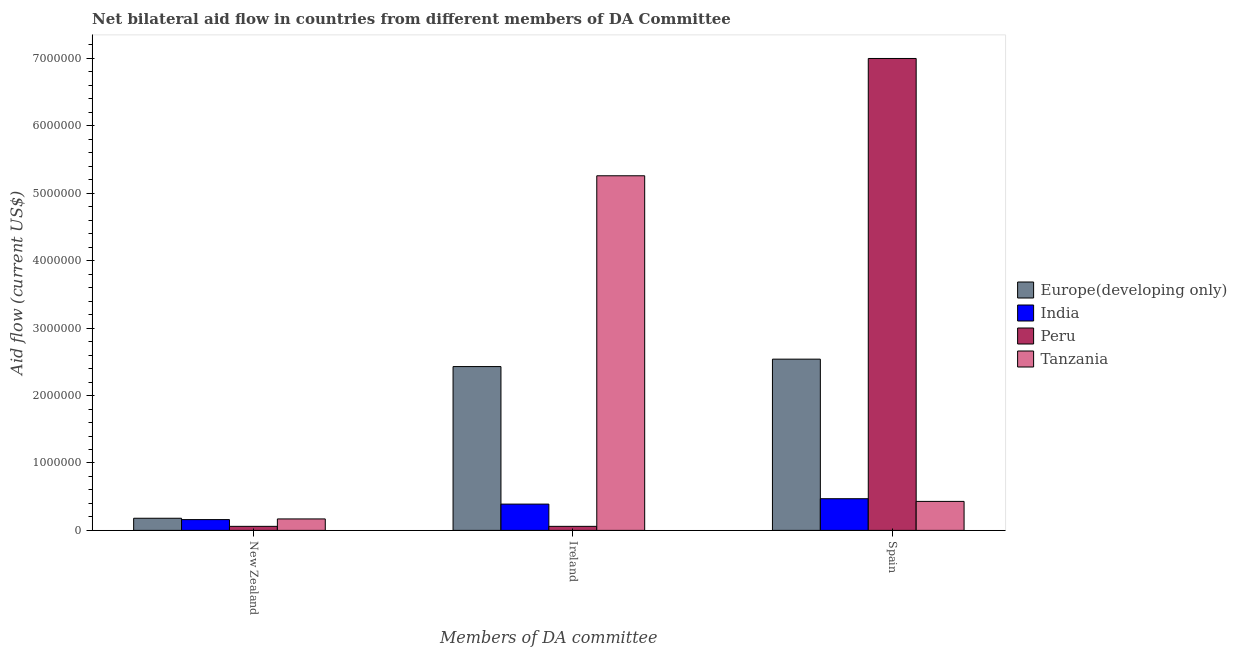How many different coloured bars are there?
Your answer should be compact. 4. How many groups of bars are there?
Your answer should be compact. 3. What is the label of the 1st group of bars from the left?
Provide a short and direct response. New Zealand. What is the amount of aid provided by ireland in Peru?
Your answer should be very brief. 6.00e+04. Across all countries, what is the maximum amount of aid provided by ireland?
Offer a terse response. 5.26e+06. Across all countries, what is the minimum amount of aid provided by spain?
Your answer should be very brief. 4.30e+05. In which country was the amount of aid provided by ireland maximum?
Provide a succinct answer. Tanzania. In which country was the amount of aid provided by spain minimum?
Make the answer very short. Tanzania. What is the total amount of aid provided by spain in the graph?
Your response must be concise. 1.04e+07. What is the difference between the amount of aid provided by new zealand in Tanzania and that in Europe(developing only)?
Provide a short and direct response. -10000. What is the difference between the amount of aid provided by ireland in Europe(developing only) and the amount of aid provided by spain in India?
Ensure brevity in your answer.  1.96e+06. What is the average amount of aid provided by spain per country?
Provide a succinct answer. 2.61e+06. What is the difference between the amount of aid provided by new zealand and amount of aid provided by spain in Tanzania?
Your answer should be compact. -2.60e+05. What is the difference between the highest and the second highest amount of aid provided by spain?
Give a very brief answer. 4.46e+06. What is the difference between the highest and the lowest amount of aid provided by ireland?
Your answer should be very brief. 5.20e+06. What does the 2nd bar from the left in New Zealand represents?
Give a very brief answer. India. What does the 3rd bar from the right in Ireland represents?
Make the answer very short. India. How many countries are there in the graph?
Provide a succinct answer. 4. What is the difference between two consecutive major ticks on the Y-axis?
Provide a succinct answer. 1.00e+06. Does the graph contain any zero values?
Keep it short and to the point. No. Does the graph contain grids?
Make the answer very short. No. Where does the legend appear in the graph?
Keep it short and to the point. Center right. How many legend labels are there?
Your answer should be very brief. 4. What is the title of the graph?
Give a very brief answer. Net bilateral aid flow in countries from different members of DA Committee. What is the label or title of the X-axis?
Your answer should be compact. Members of DA committee. What is the Aid flow (current US$) in India in New Zealand?
Give a very brief answer. 1.60e+05. What is the Aid flow (current US$) of Europe(developing only) in Ireland?
Offer a very short reply. 2.43e+06. What is the Aid flow (current US$) of Tanzania in Ireland?
Ensure brevity in your answer.  5.26e+06. What is the Aid flow (current US$) in Europe(developing only) in Spain?
Offer a terse response. 2.54e+06. What is the Aid flow (current US$) in India in Spain?
Ensure brevity in your answer.  4.70e+05. What is the Aid flow (current US$) in Peru in Spain?
Give a very brief answer. 7.00e+06. What is the Aid flow (current US$) in Tanzania in Spain?
Your answer should be compact. 4.30e+05. Across all Members of DA committee, what is the maximum Aid flow (current US$) of Europe(developing only)?
Your answer should be very brief. 2.54e+06. Across all Members of DA committee, what is the maximum Aid flow (current US$) of Tanzania?
Ensure brevity in your answer.  5.26e+06. Across all Members of DA committee, what is the minimum Aid flow (current US$) in Europe(developing only)?
Offer a terse response. 1.80e+05. Across all Members of DA committee, what is the minimum Aid flow (current US$) of Peru?
Offer a terse response. 6.00e+04. What is the total Aid flow (current US$) of Europe(developing only) in the graph?
Your answer should be compact. 5.15e+06. What is the total Aid flow (current US$) of India in the graph?
Provide a succinct answer. 1.02e+06. What is the total Aid flow (current US$) of Peru in the graph?
Provide a succinct answer. 7.12e+06. What is the total Aid flow (current US$) of Tanzania in the graph?
Offer a very short reply. 5.86e+06. What is the difference between the Aid flow (current US$) of Europe(developing only) in New Zealand and that in Ireland?
Give a very brief answer. -2.25e+06. What is the difference between the Aid flow (current US$) in India in New Zealand and that in Ireland?
Offer a terse response. -2.30e+05. What is the difference between the Aid flow (current US$) of Peru in New Zealand and that in Ireland?
Your answer should be very brief. 0. What is the difference between the Aid flow (current US$) in Tanzania in New Zealand and that in Ireland?
Provide a succinct answer. -5.09e+06. What is the difference between the Aid flow (current US$) of Europe(developing only) in New Zealand and that in Spain?
Keep it short and to the point. -2.36e+06. What is the difference between the Aid flow (current US$) in India in New Zealand and that in Spain?
Your response must be concise. -3.10e+05. What is the difference between the Aid flow (current US$) in Peru in New Zealand and that in Spain?
Your answer should be very brief. -6.94e+06. What is the difference between the Aid flow (current US$) in India in Ireland and that in Spain?
Give a very brief answer. -8.00e+04. What is the difference between the Aid flow (current US$) in Peru in Ireland and that in Spain?
Offer a terse response. -6.94e+06. What is the difference between the Aid flow (current US$) of Tanzania in Ireland and that in Spain?
Your answer should be compact. 4.83e+06. What is the difference between the Aid flow (current US$) of Europe(developing only) in New Zealand and the Aid flow (current US$) of India in Ireland?
Keep it short and to the point. -2.10e+05. What is the difference between the Aid flow (current US$) of Europe(developing only) in New Zealand and the Aid flow (current US$) of Tanzania in Ireland?
Give a very brief answer. -5.08e+06. What is the difference between the Aid flow (current US$) in India in New Zealand and the Aid flow (current US$) in Peru in Ireland?
Give a very brief answer. 1.00e+05. What is the difference between the Aid flow (current US$) of India in New Zealand and the Aid flow (current US$) of Tanzania in Ireland?
Keep it short and to the point. -5.10e+06. What is the difference between the Aid flow (current US$) of Peru in New Zealand and the Aid flow (current US$) of Tanzania in Ireland?
Provide a short and direct response. -5.20e+06. What is the difference between the Aid flow (current US$) in Europe(developing only) in New Zealand and the Aid flow (current US$) in Peru in Spain?
Keep it short and to the point. -6.82e+06. What is the difference between the Aid flow (current US$) in Europe(developing only) in New Zealand and the Aid flow (current US$) in Tanzania in Spain?
Make the answer very short. -2.50e+05. What is the difference between the Aid flow (current US$) of India in New Zealand and the Aid flow (current US$) of Peru in Spain?
Make the answer very short. -6.84e+06. What is the difference between the Aid flow (current US$) in India in New Zealand and the Aid flow (current US$) in Tanzania in Spain?
Provide a short and direct response. -2.70e+05. What is the difference between the Aid flow (current US$) in Peru in New Zealand and the Aid flow (current US$) in Tanzania in Spain?
Provide a short and direct response. -3.70e+05. What is the difference between the Aid flow (current US$) of Europe(developing only) in Ireland and the Aid flow (current US$) of India in Spain?
Offer a very short reply. 1.96e+06. What is the difference between the Aid flow (current US$) of Europe(developing only) in Ireland and the Aid flow (current US$) of Peru in Spain?
Your answer should be compact. -4.57e+06. What is the difference between the Aid flow (current US$) of India in Ireland and the Aid flow (current US$) of Peru in Spain?
Make the answer very short. -6.61e+06. What is the difference between the Aid flow (current US$) in India in Ireland and the Aid flow (current US$) in Tanzania in Spain?
Ensure brevity in your answer.  -4.00e+04. What is the difference between the Aid flow (current US$) in Peru in Ireland and the Aid flow (current US$) in Tanzania in Spain?
Your answer should be very brief. -3.70e+05. What is the average Aid flow (current US$) of Europe(developing only) per Members of DA committee?
Provide a short and direct response. 1.72e+06. What is the average Aid flow (current US$) of India per Members of DA committee?
Offer a terse response. 3.40e+05. What is the average Aid flow (current US$) in Peru per Members of DA committee?
Offer a very short reply. 2.37e+06. What is the average Aid flow (current US$) of Tanzania per Members of DA committee?
Make the answer very short. 1.95e+06. What is the difference between the Aid flow (current US$) in Europe(developing only) and Aid flow (current US$) in India in New Zealand?
Provide a succinct answer. 2.00e+04. What is the difference between the Aid flow (current US$) of Europe(developing only) and Aid flow (current US$) of Peru in New Zealand?
Offer a very short reply. 1.20e+05. What is the difference between the Aid flow (current US$) of Europe(developing only) and Aid flow (current US$) of Tanzania in New Zealand?
Your answer should be very brief. 10000. What is the difference between the Aid flow (current US$) of India and Aid flow (current US$) of Tanzania in New Zealand?
Your answer should be very brief. -10000. What is the difference between the Aid flow (current US$) in Europe(developing only) and Aid flow (current US$) in India in Ireland?
Offer a very short reply. 2.04e+06. What is the difference between the Aid flow (current US$) in Europe(developing only) and Aid flow (current US$) in Peru in Ireland?
Offer a very short reply. 2.37e+06. What is the difference between the Aid flow (current US$) in Europe(developing only) and Aid flow (current US$) in Tanzania in Ireland?
Keep it short and to the point. -2.83e+06. What is the difference between the Aid flow (current US$) of India and Aid flow (current US$) of Peru in Ireland?
Offer a very short reply. 3.30e+05. What is the difference between the Aid flow (current US$) in India and Aid flow (current US$) in Tanzania in Ireland?
Provide a succinct answer. -4.87e+06. What is the difference between the Aid flow (current US$) in Peru and Aid flow (current US$) in Tanzania in Ireland?
Your answer should be very brief. -5.20e+06. What is the difference between the Aid flow (current US$) in Europe(developing only) and Aid flow (current US$) in India in Spain?
Ensure brevity in your answer.  2.07e+06. What is the difference between the Aid flow (current US$) in Europe(developing only) and Aid flow (current US$) in Peru in Spain?
Offer a very short reply. -4.46e+06. What is the difference between the Aid flow (current US$) of Europe(developing only) and Aid flow (current US$) of Tanzania in Spain?
Your answer should be very brief. 2.11e+06. What is the difference between the Aid flow (current US$) of India and Aid flow (current US$) of Peru in Spain?
Your answer should be very brief. -6.53e+06. What is the difference between the Aid flow (current US$) of India and Aid flow (current US$) of Tanzania in Spain?
Provide a succinct answer. 4.00e+04. What is the difference between the Aid flow (current US$) in Peru and Aid flow (current US$) in Tanzania in Spain?
Your answer should be very brief. 6.57e+06. What is the ratio of the Aid flow (current US$) in Europe(developing only) in New Zealand to that in Ireland?
Your response must be concise. 0.07. What is the ratio of the Aid flow (current US$) in India in New Zealand to that in Ireland?
Your response must be concise. 0.41. What is the ratio of the Aid flow (current US$) in Peru in New Zealand to that in Ireland?
Ensure brevity in your answer.  1. What is the ratio of the Aid flow (current US$) of Tanzania in New Zealand to that in Ireland?
Give a very brief answer. 0.03. What is the ratio of the Aid flow (current US$) of Europe(developing only) in New Zealand to that in Spain?
Your response must be concise. 0.07. What is the ratio of the Aid flow (current US$) of India in New Zealand to that in Spain?
Your response must be concise. 0.34. What is the ratio of the Aid flow (current US$) in Peru in New Zealand to that in Spain?
Ensure brevity in your answer.  0.01. What is the ratio of the Aid flow (current US$) in Tanzania in New Zealand to that in Spain?
Give a very brief answer. 0.4. What is the ratio of the Aid flow (current US$) of Europe(developing only) in Ireland to that in Spain?
Your response must be concise. 0.96. What is the ratio of the Aid flow (current US$) in India in Ireland to that in Spain?
Give a very brief answer. 0.83. What is the ratio of the Aid flow (current US$) of Peru in Ireland to that in Spain?
Provide a succinct answer. 0.01. What is the ratio of the Aid flow (current US$) of Tanzania in Ireland to that in Spain?
Keep it short and to the point. 12.23. What is the difference between the highest and the second highest Aid flow (current US$) of Europe(developing only)?
Your answer should be compact. 1.10e+05. What is the difference between the highest and the second highest Aid flow (current US$) of India?
Ensure brevity in your answer.  8.00e+04. What is the difference between the highest and the second highest Aid flow (current US$) of Peru?
Make the answer very short. 6.94e+06. What is the difference between the highest and the second highest Aid flow (current US$) of Tanzania?
Ensure brevity in your answer.  4.83e+06. What is the difference between the highest and the lowest Aid flow (current US$) of Europe(developing only)?
Provide a short and direct response. 2.36e+06. What is the difference between the highest and the lowest Aid flow (current US$) of India?
Keep it short and to the point. 3.10e+05. What is the difference between the highest and the lowest Aid flow (current US$) in Peru?
Your answer should be compact. 6.94e+06. What is the difference between the highest and the lowest Aid flow (current US$) in Tanzania?
Your answer should be compact. 5.09e+06. 